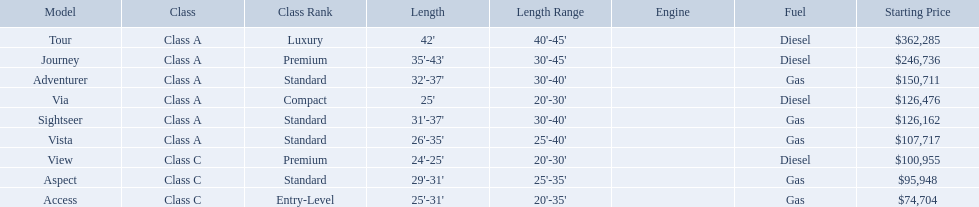Which of the models in the table use diesel fuel? Tour, Journey, Via, View. Of these models, which are class a? Tour, Journey, Via. Which of them are greater than 35' in length? Tour, Journey. Which of the two models is more expensive? Tour. Which models of winnebago are there? Tour, Journey, Adventurer, Via, Sightseer, Vista, View, Aspect, Access. Which ones are diesel? Tour, Journey, Sightseer, View. Which of those is the longest? Tour, Journey. Which one has the highest starting price? Tour. What are all the class a models of the winnebago industries? Tour, Journey, Adventurer, Via, Sightseer, Vista. Of those class a models, which has the highest starting price? Tour. What models are available from winnebago industries? Tour, Journey, Adventurer, Via, Sightseer, Vista, View, Aspect, Access. What are their starting prices? $362,285, $246,736, $150,711, $126,476, $126,162, $107,717, $100,955, $95,948, $74,704. Which model has the most costly starting price? Tour. What are the prices? $362,285, $246,736, $150,711, $126,476, $126,162, $107,717, $100,955, $95,948, $74,704. What is the top price? $362,285. What model has this price? Tour. 